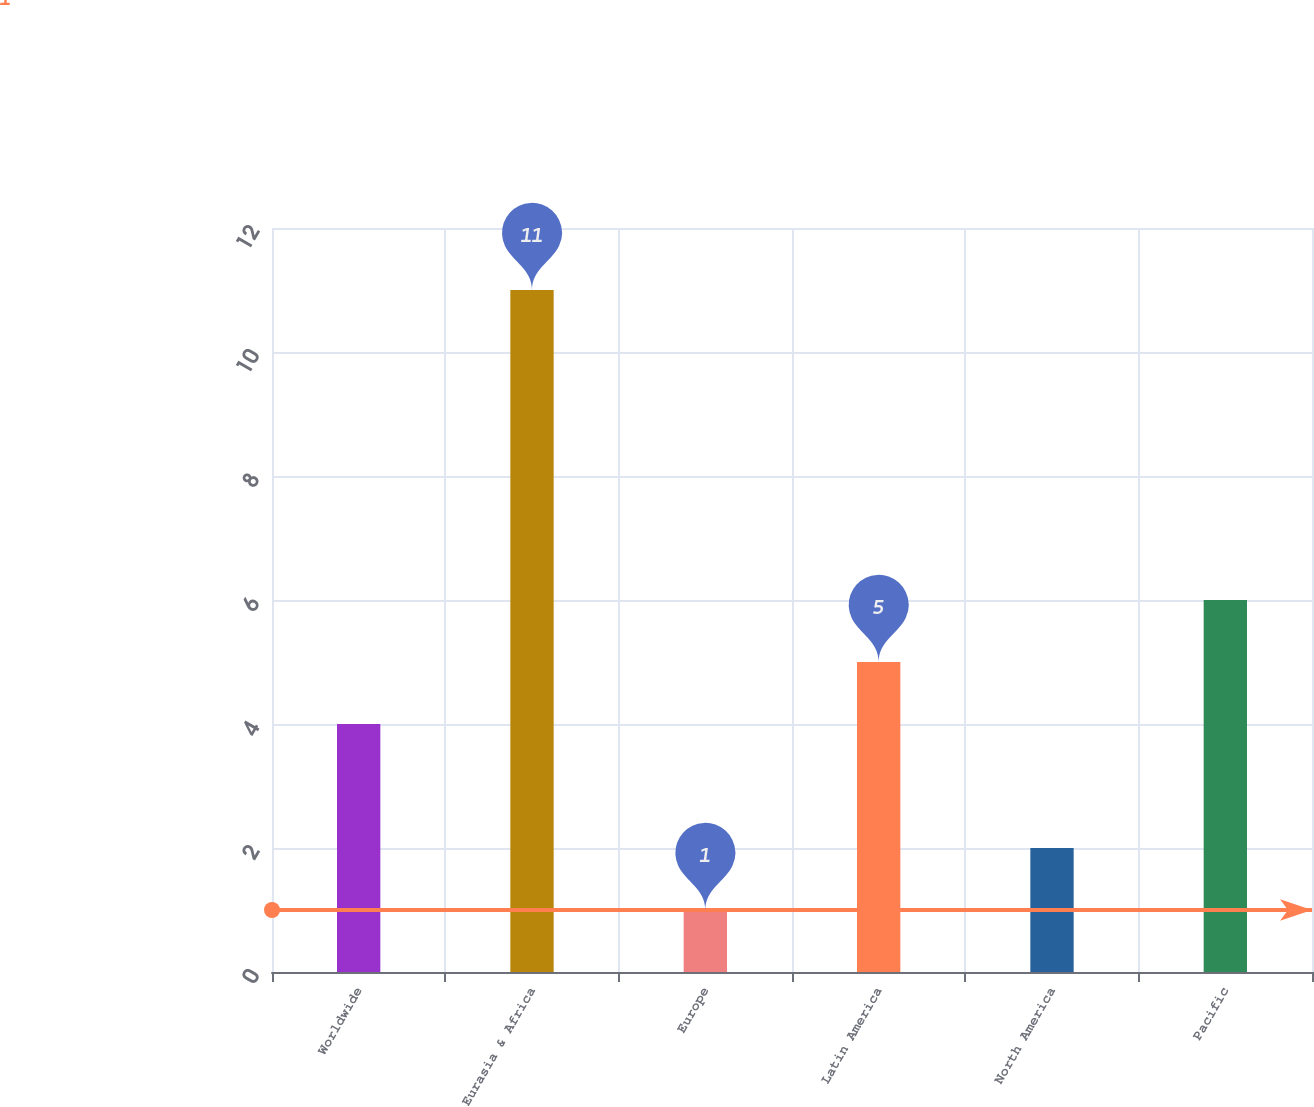Convert chart. <chart><loc_0><loc_0><loc_500><loc_500><bar_chart><fcel>Worldwide<fcel>Eurasia & Africa<fcel>Europe<fcel>Latin America<fcel>North America<fcel>Pacific<nl><fcel>4<fcel>11<fcel>1<fcel>5<fcel>2<fcel>6<nl></chart> 